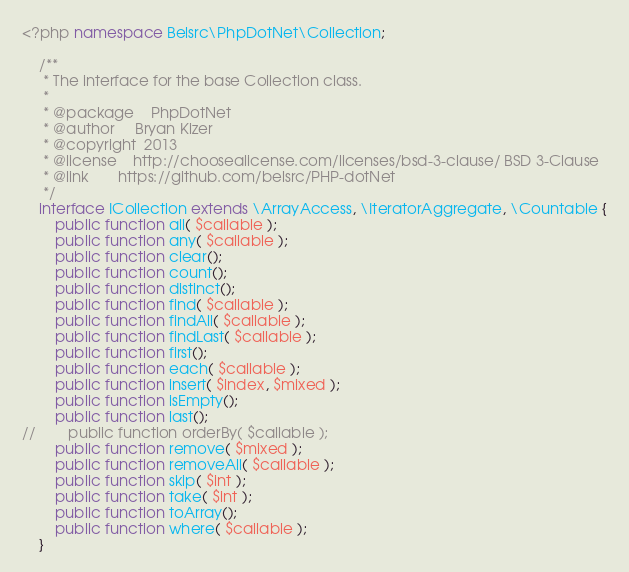Convert code to text. <code><loc_0><loc_0><loc_500><loc_500><_PHP_><?php namespace Belsrc\PhpDotNet\Collection;

    /**
     * The interface for the base Collection class.
     *
     * @package    PhpDotNet
     * @author     Bryan Kizer
     * @copyright  2013
     * @license    http://choosealicense.com/licenses/bsd-3-clause/ BSD 3-Clause
     * @link       https://github.com/belsrc/PHP-dotNet
     */
    interface ICollection extends \ArrayAccess, \IteratorAggregate, \Countable {
        public function all( $callable );
        public function any( $callable );
        public function clear();
        public function count();
        public function distinct();
        public function find( $callable );
        public function findAll( $callable );
        public function findLast( $callable );
        public function first();
        public function each( $callable );
        public function insert( $index, $mixed );
        public function isEmpty();
        public function last();
//        public function orderBy( $callable );
        public function remove( $mixed );
        public function removeAll( $callable );
        public function skip( $int );
        public function take( $int );
        public function toArray();
        public function where( $callable );
    }
</code> 